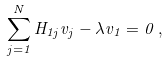<formula> <loc_0><loc_0><loc_500><loc_500>\sum _ { j = 1 } ^ { N } H _ { 1 j } v _ { j } - \lambda v _ { 1 } = 0 \, ,</formula> 